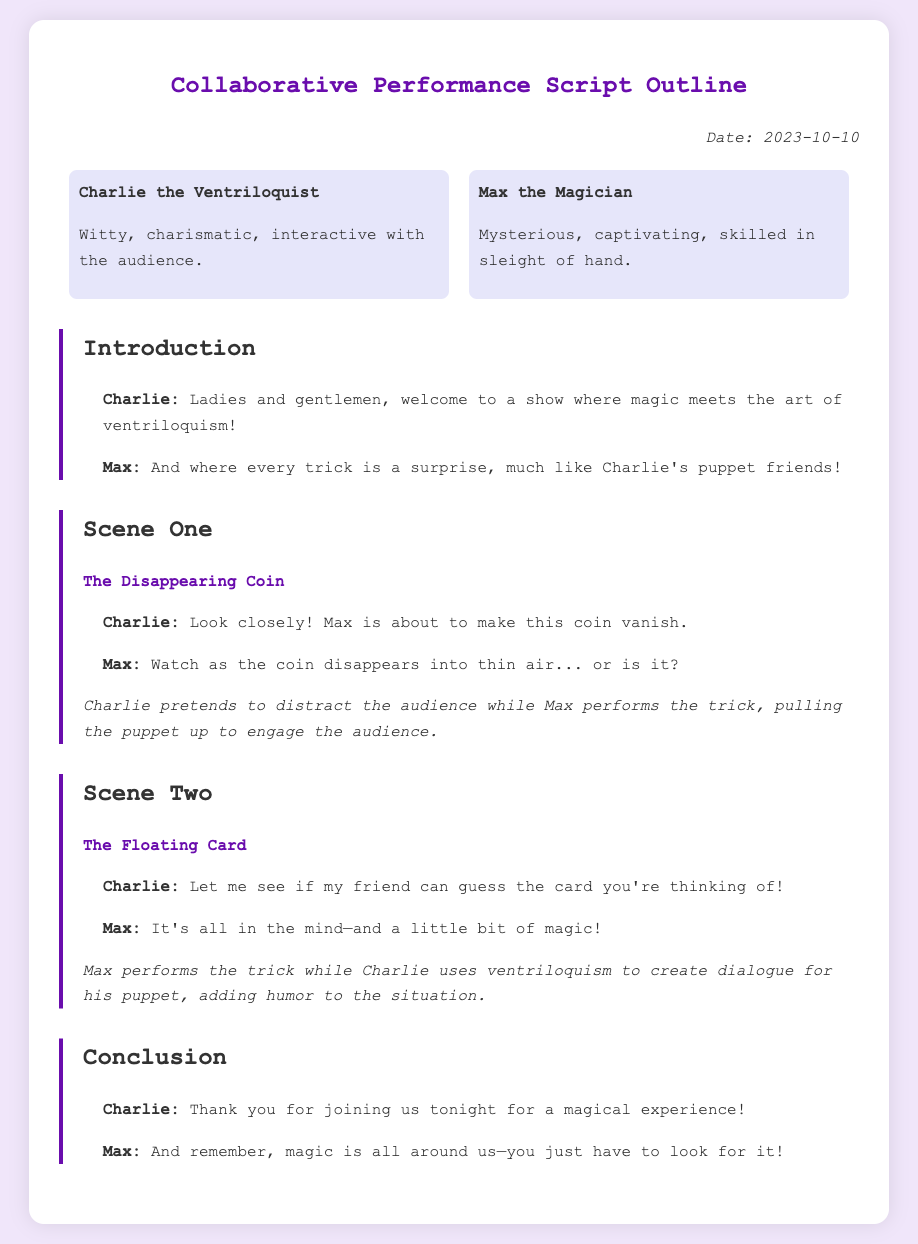What date was the memo created? The date of the memo is explicitly mentioned at the top under "Date".
Answer: 2023-10-10 Who are the two main participants in the performance? The two participants' names are listed in the "participants" section of the memo.
Answer: Charlie the Ventriloquist and Max the Magician What is the first magical trick performed in the show? The name of the first magical trick is clearly stated in "Scene One".
Answer: The Disappearing Coin How does Charlie engage the audience during the first trick? The memo describes Charlie's action during the trick in the "interaction" following the dialogue.
Answer: Pretends to distract the audience What does Max say about magic at the end of the show? The final lines spoken by Max in the "Conclusion" section provide this information.
Answer: Magic is all around us—you just have to look for it! 